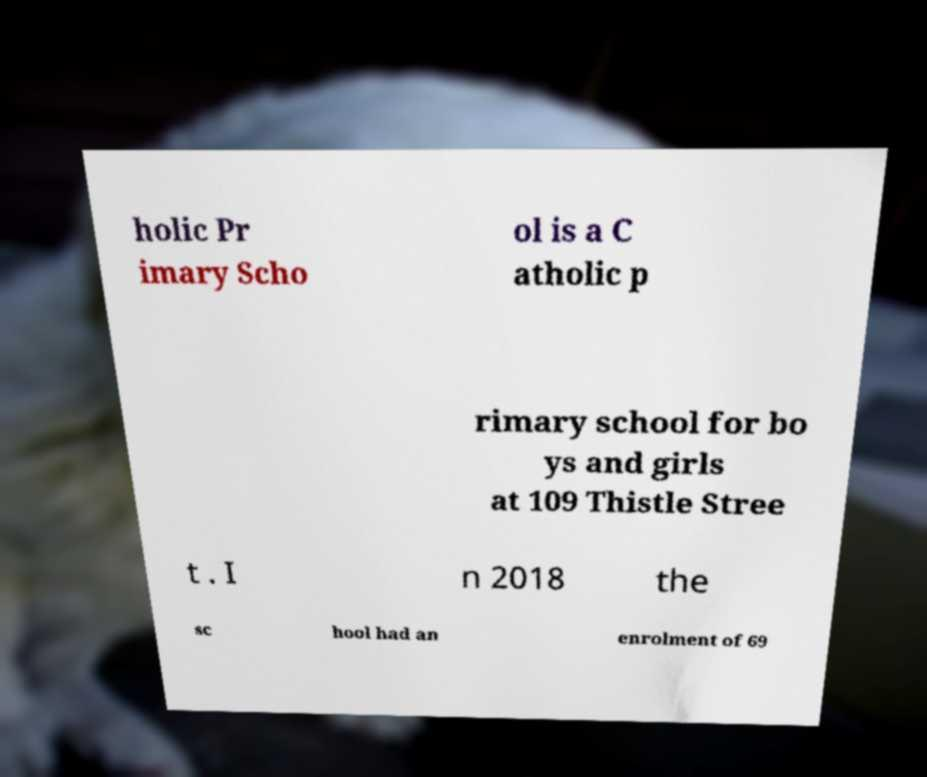There's text embedded in this image that I need extracted. Can you transcribe it verbatim? holic Pr imary Scho ol is a C atholic p rimary school for bo ys and girls at 109 Thistle Stree t . I n 2018 the sc hool had an enrolment of 69 